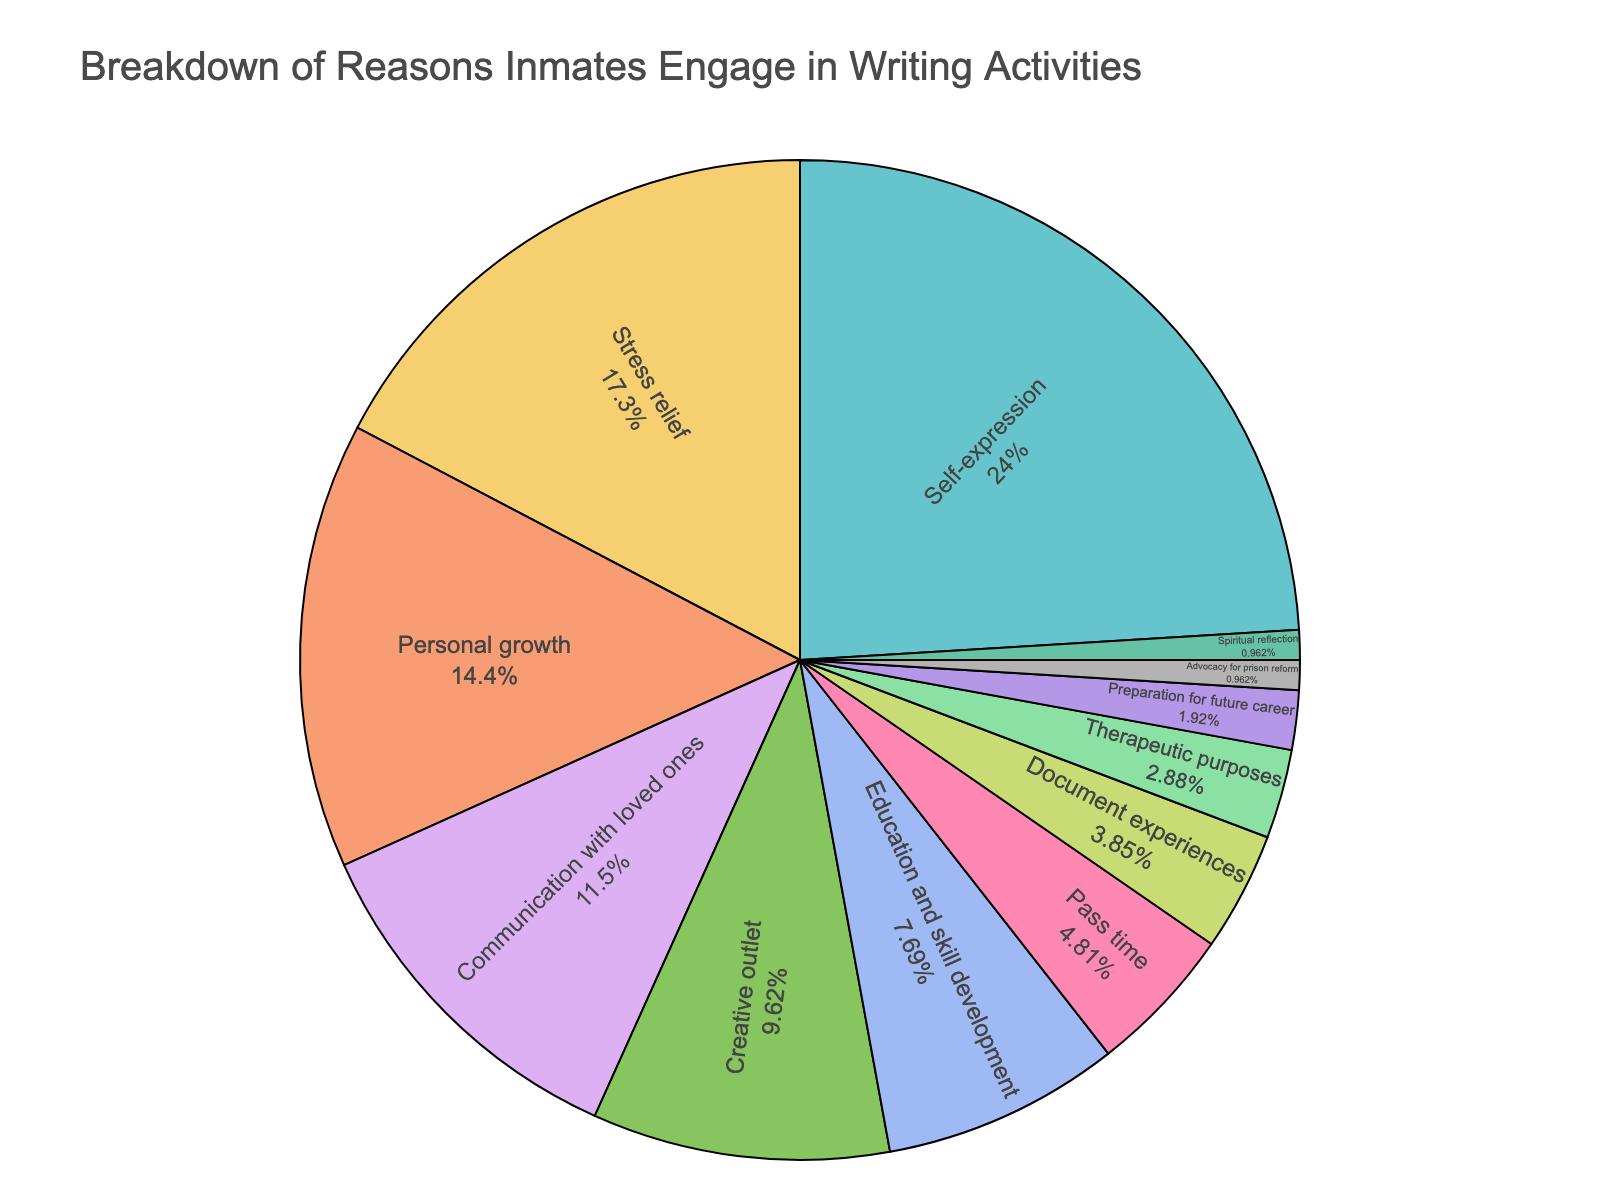What's the most common reason inmates cite for engaging in writing activities? The pie chart shows the percentages for various reasons inmates engage in writing activities. The largest slice represents "Self-expression" at 25%.
Answer: Self-expression What's the combined percentage of inmates who write for stress relief and personal growth? The chart indicates that 18% of inmates write for stress relief and 15% for personal growth. Adding these percentages gives 18 + 15 = 33%.
Answer: 33% Which category occupies a larger portion of the chart, education and skill development or pass time? Education and skill development has 8% while pass time has 5%, making education and skill development a larger portion.
Answer: Education and skill development How does the percentage for communication with loved ones compare to the percentage for creative outlet? The pie chart shows that communication with loved ones is 12% and creative outlet is 10%. Communication with loved ones is greater than creative outlet.
Answer: Communication with loved ones is greater What is the total percentage for categories below 5%? Adding the percentages for Pass time (5%), Document experiences (4%), Therapeutic purposes (3%), Preparation for future career (2%), Advocacy for prison reform (1%), and Spiritual reflection (1%), we get 5 + 4 + 3 + 2 + 1 + 1 = 16%.
Answer: 16% What percentage of inmates cite therapeutic purposes for their writing activities? The pie chart indicates that 3% of inmates engage in writing for therapeutic purposes.
Answer: 3% How much more significant is self-expression as a reason compared to communication with loved ones? Self-expression sits at 25% while communication with loved ones is at 12%. The difference is 25 - 12 = 13%.
Answer: 13% Which two categories combined make up exactly 23% of the reasons? Adding 18% (Stress relief) and 5% (Pass time) equals 23%.
Answer: Stress relief and Pass time Observing the chart, which category is represented by the smallest section? The chart shows that Advocacy for prison reform and Spiritual reflection each have the smallest section of 1%.
Answer: Advocacy for prison reform and Spiritual reflection 